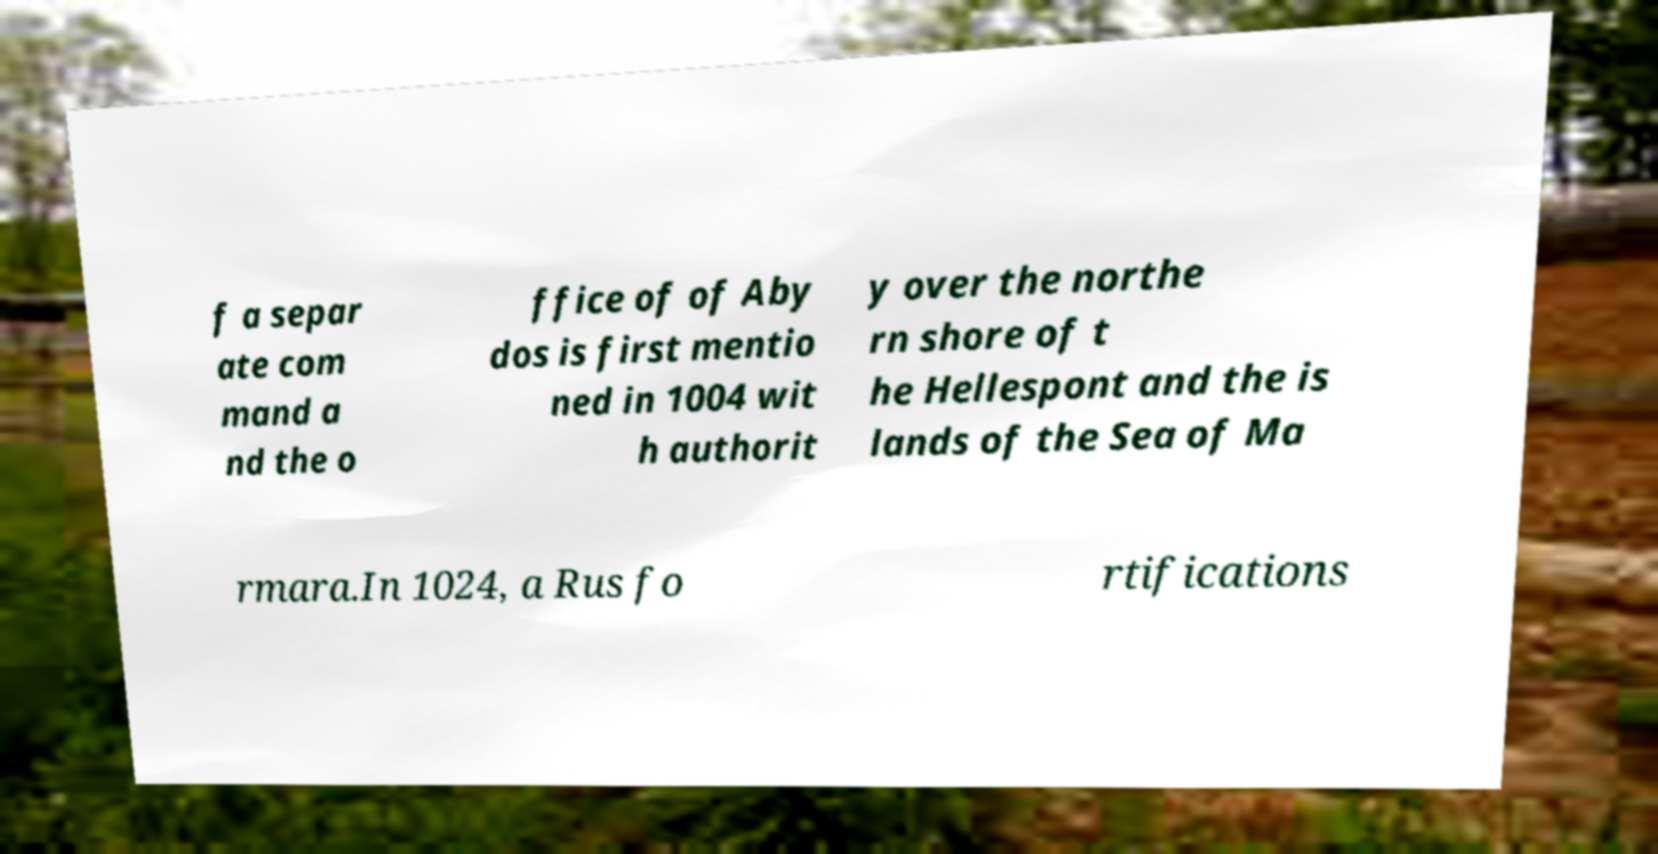Could you extract and type out the text from this image? f a separ ate com mand a nd the o ffice of of Aby dos is first mentio ned in 1004 wit h authorit y over the northe rn shore of t he Hellespont and the is lands of the Sea of Ma rmara.In 1024, a Rus fo rtifications 